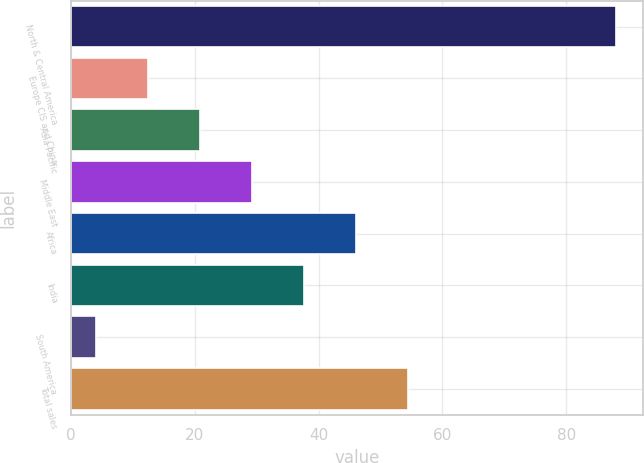<chart> <loc_0><loc_0><loc_500><loc_500><bar_chart><fcel>North & Central America<fcel>Europe CIS and China<fcel>Asia Pacific<fcel>Middle East<fcel>Africa<fcel>India<fcel>South America<fcel>Total sales<nl><fcel>88<fcel>12.4<fcel>20.8<fcel>29.2<fcel>46<fcel>37.6<fcel>4<fcel>54.4<nl></chart> 